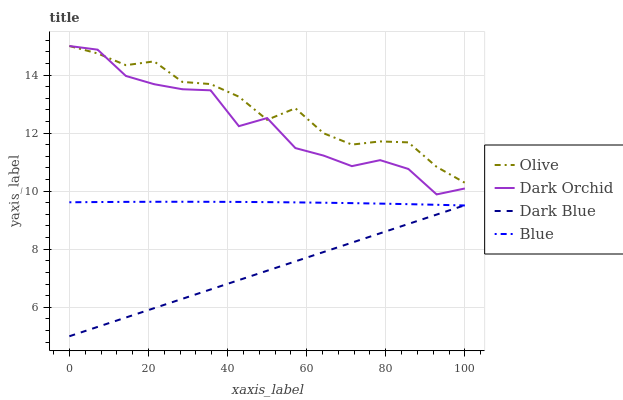Does Dark Blue have the minimum area under the curve?
Answer yes or no. Yes. Does Olive have the maximum area under the curve?
Answer yes or no. Yes. Does Dark Orchid have the minimum area under the curve?
Answer yes or no. No. Does Dark Orchid have the maximum area under the curve?
Answer yes or no. No. Is Dark Blue the smoothest?
Answer yes or no. Yes. Is Dark Orchid the roughest?
Answer yes or no. Yes. Is Dark Orchid the smoothest?
Answer yes or no. No. Is Dark Blue the roughest?
Answer yes or no. No. Does Dark Orchid have the lowest value?
Answer yes or no. No. Does Dark Orchid have the highest value?
Answer yes or no. Yes. Does Dark Blue have the highest value?
Answer yes or no. No. Is Blue less than Olive?
Answer yes or no. Yes. Is Dark Orchid greater than Dark Blue?
Answer yes or no. Yes. Does Blue intersect Olive?
Answer yes or no. No. 